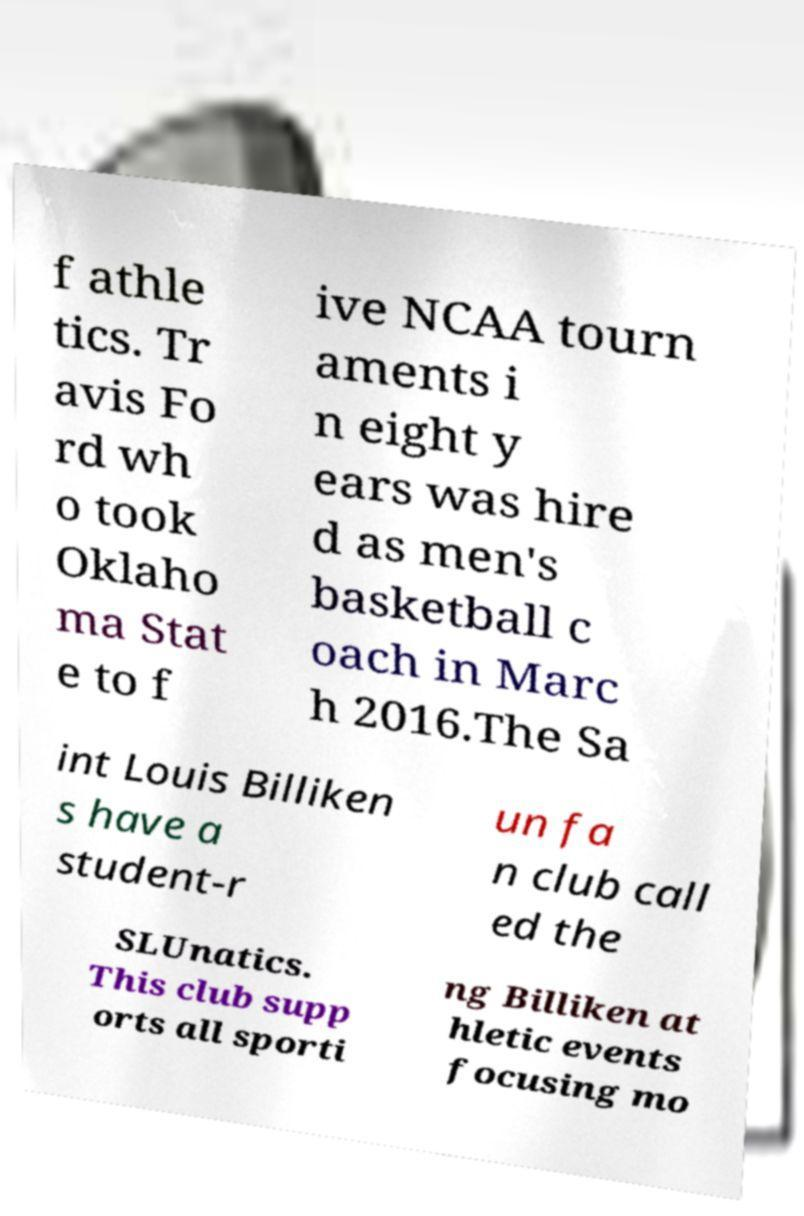Could you assist in decoding the text presented in this image and type it out clearly? f athle tics. Tr avis Fo rd wh o took Oklaho ma Stat e to f ive NCAA tourn aments i n eight y ears was hire d as men's basketball c oach in Marc h 2016.The Sa int Louis Billiken s have a student-r un fa n club call ed the SLUnatics. This club supp orts all sporti ng Billiken at hletic events focusing mo 